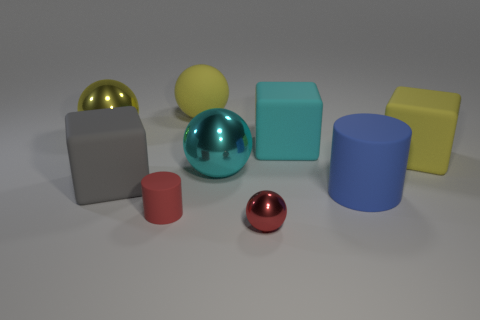There is a sphere that is the same color as the tiny matte object; what is it made of?
Your answer should be very brief. Metal. How many rubber things are behind the small cylinder and right of the large gray cube?
Offer a terse response. 4. There is a big sphere behind the large metallic thing to the left of the yellow rubber sphere; what is its material?
Your answer should be very brief. Rubber. Are there any other large blue cylinders made of the same material as the big cylinder?
Offer a very short reply. No. What is the material of the cyan sphere that is the same size as the yellow cube?
Your response must be concise. Metal. There is a matte block right of the rubber cube that is behind the yellow thing right of the tiny red shiny sphere; what size is it?
Provide a short and direct response. Large. Are there any tiny red spheres that are behind the large rubber cube behind the big yellow block?
Your answer should be compact. No. Do the large gray object and the large yellow thing that is to the right of the large cyan ball have the same shape?
Your response must be concise. Yes. What is the color of the block that is to the left of the tiny metal sphere?
Provide a short and direct response. Gray. There is a yellow object right of the tiny red thing right of the tiny cylinder; what is its size?
Give a very brief answer. Large. 